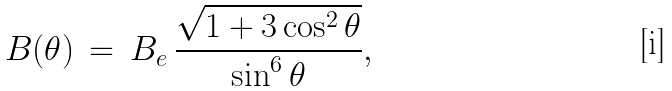<formula> <loc_0><loc_0><loc_500><loc_500>B ( \theta ) \, = \, B _ { e } \, \frac { \sqrt { 1 + 3 \cos ^ { 2 } \theta } } { \sin ^ { 6 } \theta } ,</formula> 